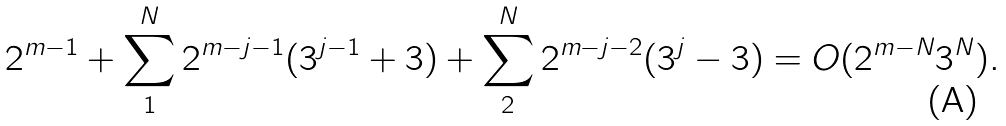<formula> <loc_0><loc_0><loc_500><loc_500>2 ^ { m - 1 } + \sum _ { 1 } ^ { N } 2 ^ { m - j - 1 } ( 3 ^ { j - 1 } + 3 ) + \sum _ { 2 } ^ { N } 2 ^ { m - j - 2 } ( 3 ^ { j } - 3 ) = O ( 2 ^ { m - N } 3 ^ { N } ) .</formula> 